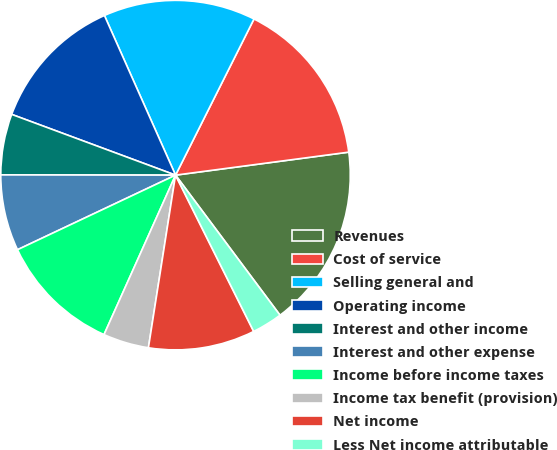<chart> <loc_0><loc_0><loc_500><loc_500><pie_chart><fcel>Revenues<fcel>Cost of service<fcel>Selling general and<fcel>Operating income<fcel>Interest and other income<fcel>Interest and other expense<fcel>Income before income taxes<fcel>Income tax benefit (provision)<fcel>Net income<fcel>Less Net income attributable<nl><fcel>16.9%<fcel>15.49%<fcel>14.08%<fcel>12.68%<fcel>5.63%<fcel>7.04%<fcel>11.27%<fcel>4.23%<fcel>9.86%<fcel>2.82%<nl></chart> 